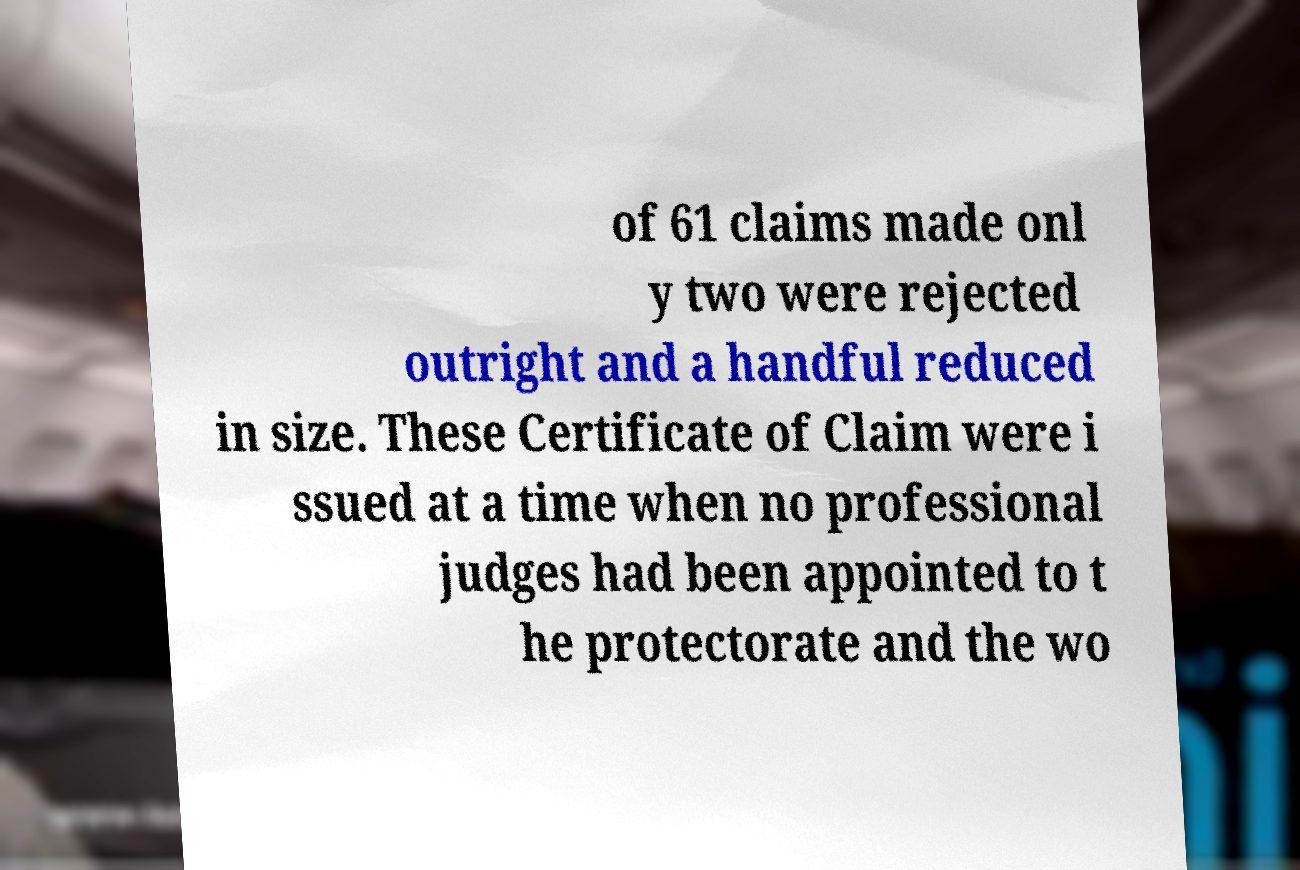Could you assist in decoding the text presented in this image and type it out clearly? of 61 claims made onl y two were rejected outright and a handful reduced in size. These Certificate of Claim were i ssued at a time when no professional judges had been appointed to t he protectorate and the wo 